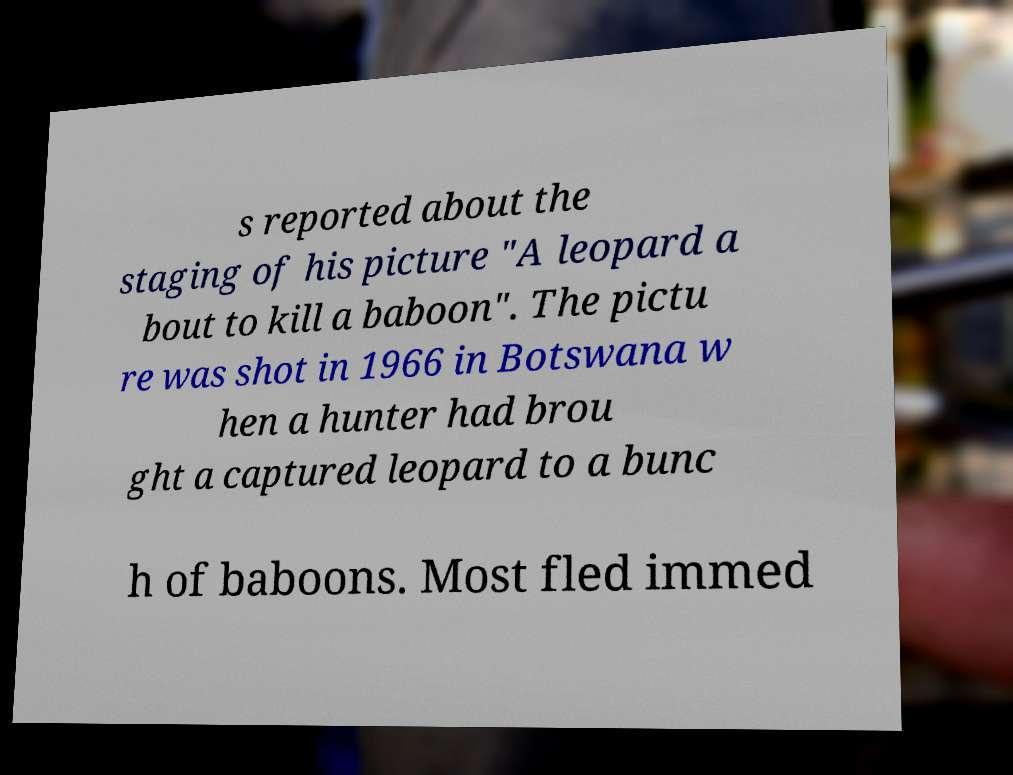Can you accurately transcribe the text from the provided image for me? s reported about the staging of his picture "A leopard a bout to kill a baboon". The pictu re was shot in 1966 in Botswana w hen a hunter had brou ght a captured leopard to a bunc h of baboons. Most fled immed 